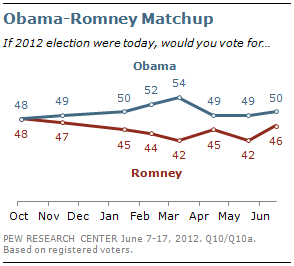Specify some key components in this picture. The data of a certain leader is displayed in a red line graph, and that leader is Romney. The average of the last three months of Romney's data is 44.33. 